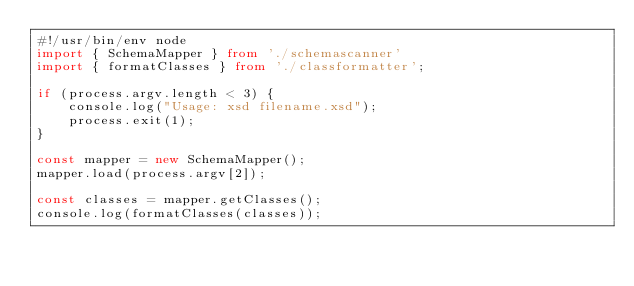Convert code to text. <code><loc_0><loc_0><loc_500><loc_500><_TypeScript_>#!/usr/bin/env node
import { SchemaMapper } from './schemascanner'
import { formatClasses } from './classformatter';

if (process.argv.length < 3) {
    console.log("Usage: xsd filename.xsd");
    process.exit(1);
}

const mapper = new SchemaMapper();
mapper.load(process.argv[2]);

const classes = mapper.getClasses();
console.log(formatClasses(classes));
</code> 